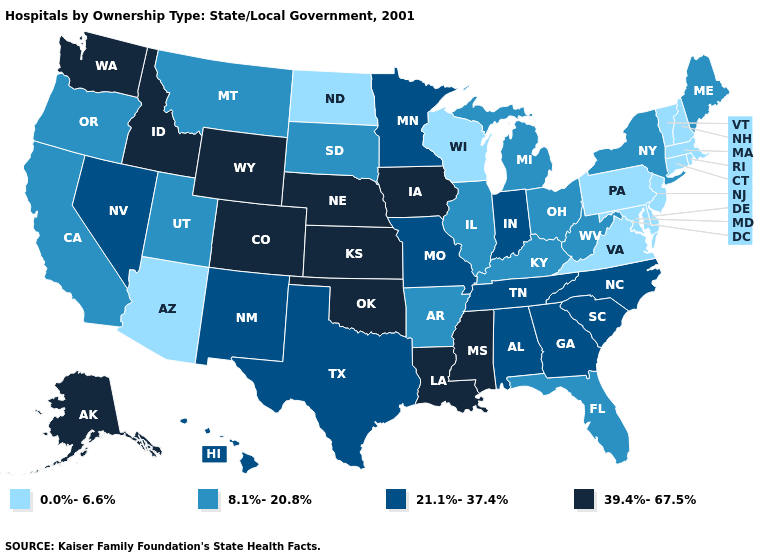What is the lowest value in the USA?
Answer briefly. 0.0%-6.6%. What is the value of New Mexico?
Answer briefly. 21.1%-37.4%. Does New York have the same value as California?
Write a very short answer. Yes. Name the states that have a value in the range 21.1%-37.4%?
Be succinct. Alabama, Georgia, Hawaii, Indiana, Minnesota, Missouri, Nevada, New Mexico, North Carolina, South Carolina, Tennessee, Texas. Name the states that have a value in the range 0.0%-6.6%?
Keep it brief. Arizona, Connecticut, Delaware, Maryland, Massachusetts, New Hampshire, New Jersey, North Dakota, Pennsylvania, Rhode Island, Vermont, Virginia, Wisconsin. What is the highest value in the USA?
Quick response, please. 39.4%-67.5%. Among the states that border New Mexico , which have the lowest value?
Quick response, please. Arizona. Which states hav the highest value in the MidWest?
Keep it brief. Iowa, Kansas, Nebraska. How many symbols are there in the legend?
Answer briefly. 4. Name the states that have a value in the range 21.1%-37.4%?
Quick response, please. Alabama, Georgia, Hawaii, Indiana, Minnesota, Missouri, Nevada, New Mexico, North Carolina, South Carolina, Tennessee, Texas. What is the value of Virginia?
Be succinct. 0.0%-6.6%. Name the states that have a value in the range 21.1%-37.4%?
Be succinct. Alabama, Georgia, Hawaii, Indiana, Minnesota, Missouri, Nevada, New Mexico, North Carolina, South Carolina, Tennessee, Texas. What is the lowest value in the USA?
Concise answer only. 0.0%-6.6%. Name the states that have a value in the range 8.1%-20.8%?
Short answer required. Arkansas, California, Florida, Illinois, Kentucky, Maine, Michigan, Montana, New York, Ohio, Oregon, South Dakota, Utah, West Virginia. 